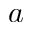<formula> <loc_0><loc_0><loc_500><loc_500>a</formula> 